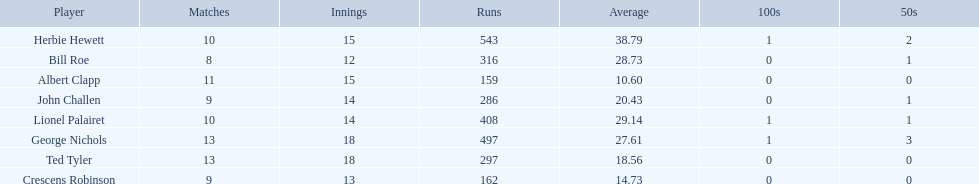Who are the players in somerset county cricket club in 1890? Herbie Hewett, Lionel Palairet, Bill Roe, George Nichols, John Challen, Ted Tyler, Crescens Robinson, Albert Clapp. Who is the only player to play less than 13 innings? Bill Roe. 